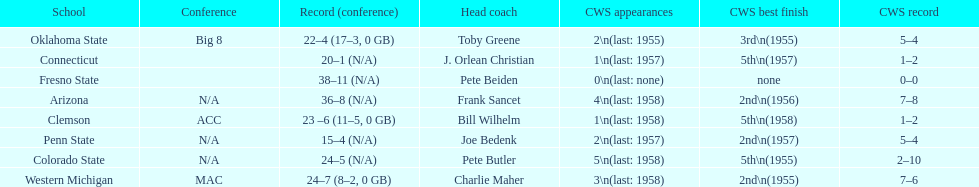Oklahoma state and penn state both have how many cws appearances? 2. Can you give me this table as a dict? {'header': ['School', 'Conference', 'Record (conference)', 'Head coach', 'CWS appearances', 'CWS best finish', 'CWS record'], 'rows': [['Oklahoma State', 'Big 8', '22–4 (17–3, 0 GB)', 'Toby Greene', '2\\n(last: 1955)', '3rd\\n(1955)', '5–4'], ['Connecticut', '', '20–1 (N/A)', 'J. Orlean Christian', '1\\n(last: 1957)', '5th\\n(1957)', '1–2'], ['Fresno State', '', '38–11 (N/A)', 'Pete Beiden', '0\\n(last: none)', 'none', '0–0'], ['Arizona', 'N/A', '36–8 (N/A)', 'Frank Sancet', '4\\n(last: 1958)', '2nd\\n(1956)', '7–8'], ['Clemson', 'ACC', '23 –6 (11–5, 0 GB)', 'Bill Wilhelm', '1\\n(last: 1958)', '5th\\n(1958)', '1–2'], ['Penn State', 'N/A', '15–4 (N/A)', 'Joe Bedenk', '2\\n(last: 1957)', '2nd\\n(1957)', '5–4'], ['Colorado State', 'N/A', '24–5 (N/A)', 'Pete Butler', '5\\n(last: 1958)', '5th\\n(1955)', '2–10'], ['Western Michigan', 'MAC', '24–7 (8–2, 0 GB)', 'Charlie Maher', '3\\n(last: 1958)', '2nd\\n(1955)', '7–6']]} 